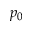<formula> <loc_0><loc_0><loc_500><loc_500>p _ { 0 }</formula> 